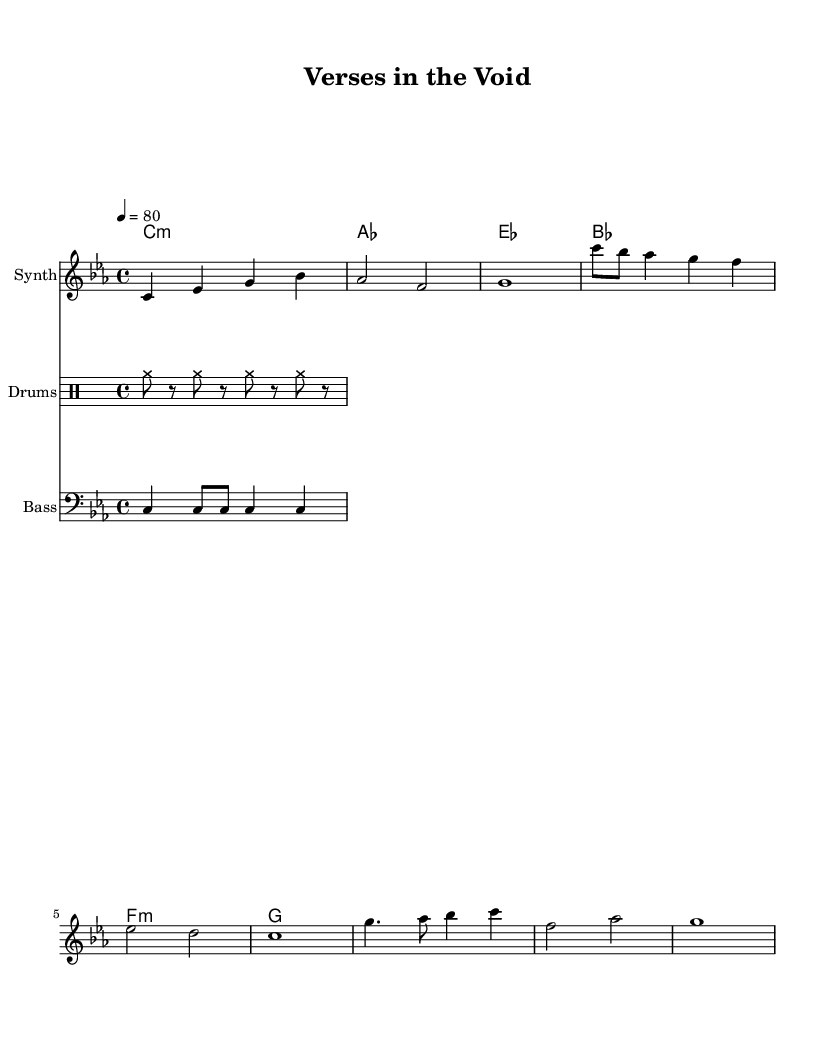What is the key signature of this music? The key signature is C minor, which includes three flats: B flat, E flat, and A flat. This can be determined by looking at the key signature notation at the beginning of the staff.
Answer: C minor What is the time signature of this music? The time signature is 4/4, indicated at the beginning of the score. This means there are four beats in a measure and a quarter note receives one beat.
Answer: 4/4 What is the tempo of this piece? The tempo is indicated as 80 beats per minute, shown at the beginning of the score with the mark "4 = 80", meaning that there are 80 quarter note beats in one minute.
Answer: 80 How many measures are in the synthesizer part? The synthesizer part contains a total of 6 measures, counting each group of notes separated by bar lines.
Answer: 6 What types of instruments are used in this piece? The piece includes synthesizer, drums, and bass, as each section is labeled with the respective instrument names in the score.
Answer: Synthesizer, Drums, Bass What chord follows the C minor chord in the progression? The chord progression moves from C minor to A flat major, which is the next chord written in the chord names section. This can be observed in the chord changes in sequence.
Answer: A flat What is the main theme of the song reflected in its composition? The main theme reflects layered voice recordings along with a synthesis of electronic sounds, indicated by the use of synthesizer and a complex structure that allows for poetic recitations. This is especially characteristic of experimental electronic music.
Answer: Experimental electronic music 